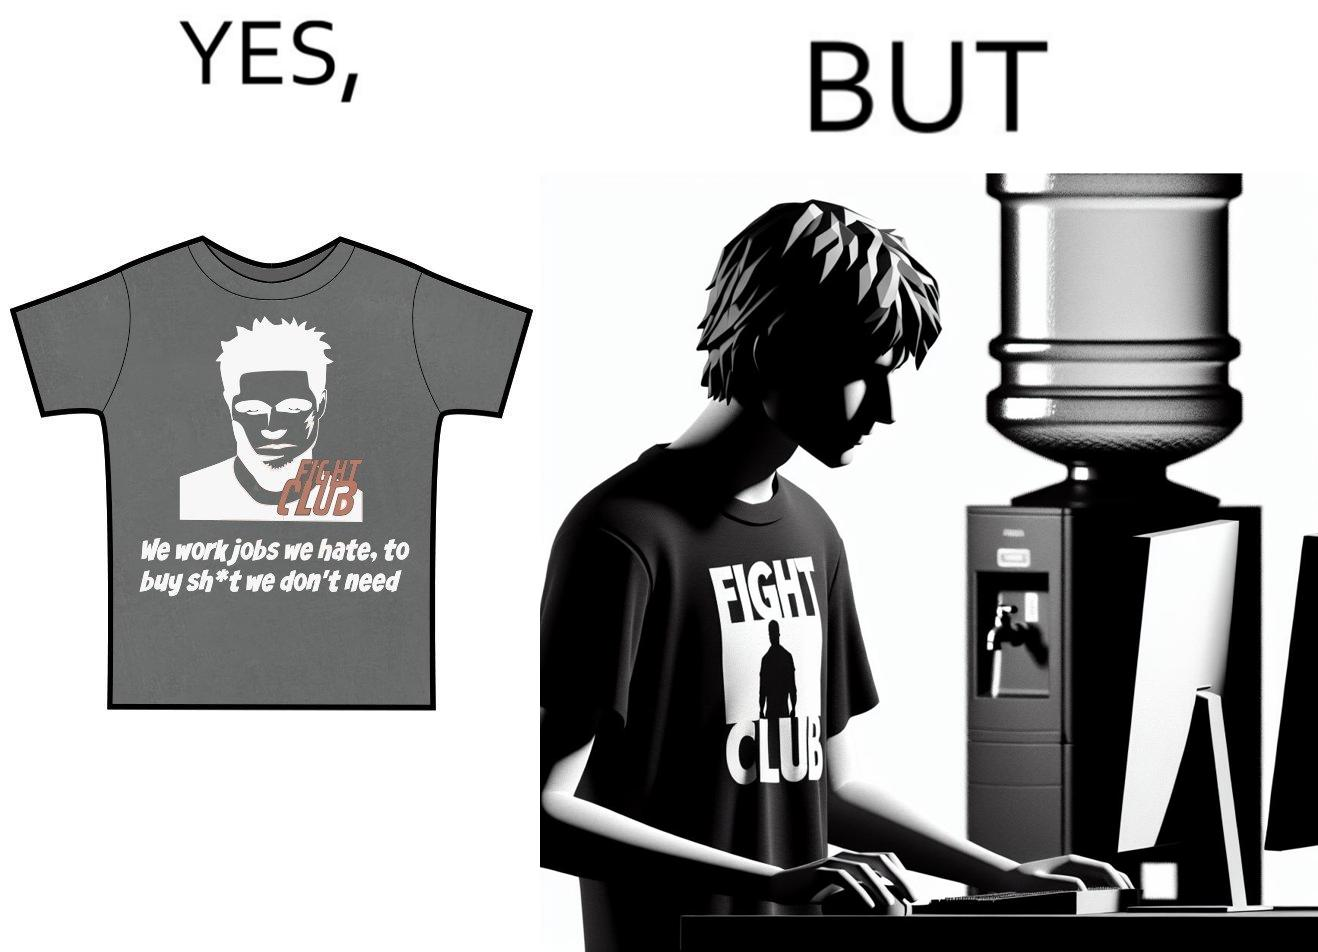What does this image depict? The image is ironical, as the t-shirt says "We work jobs we hate, to buy sh*t we don't need", which is a rebellious message against the construct of office jobs. However, the person wearing the t-shirt seems to be working in an office environment. Also, the t-shirt might have been bought using the money earned via the very same job. 